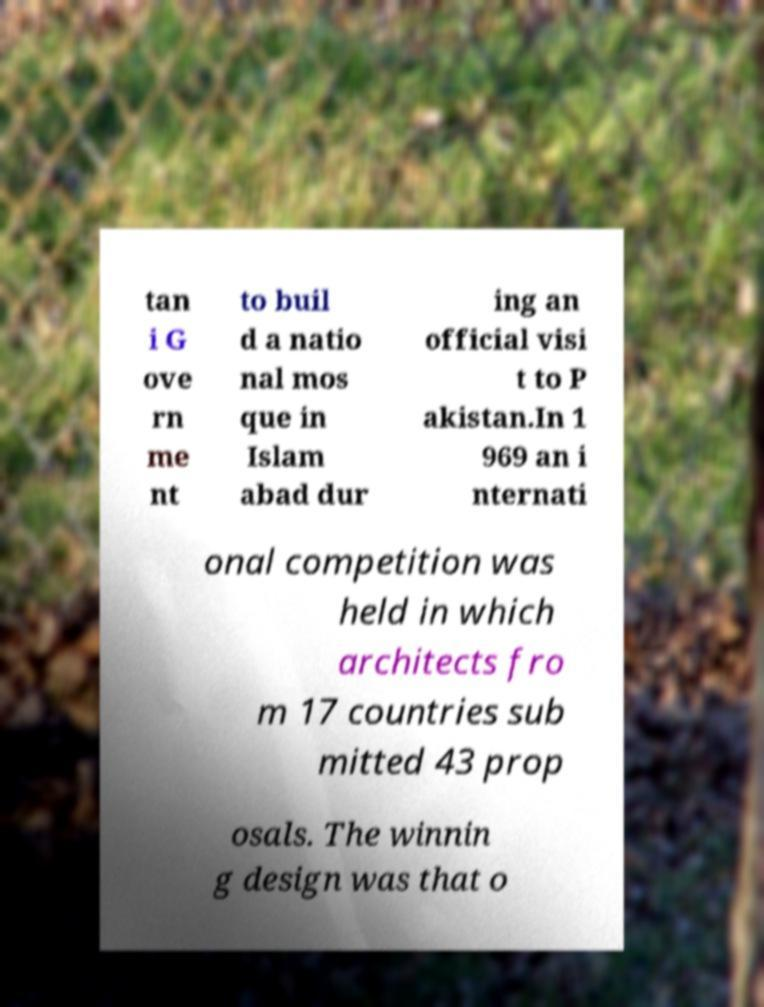Could you extract and type out the text from this image? tan i G ove rn me nt to buil d a natio nal mos que in Islam abad dur ing an official visi t to P akistan.In 1 969 an i nternati onal competition was held in which architects fro m 17 countries sub mitted 43 prop osals. The winnin g design was that o 